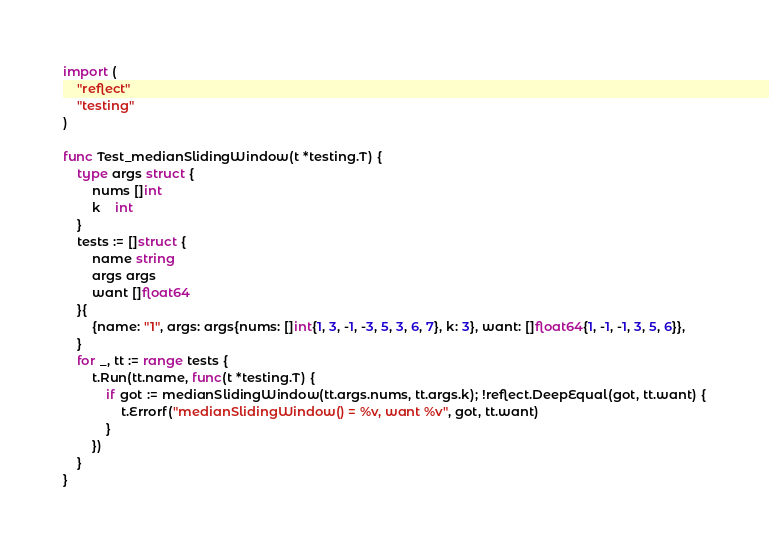<code> <loc_0><loc_0><loc_500><loc_500><_Go_>
import (
	"reflect"
	"testing"
)

func Test_medianSlidingWindow(t *testing.T) {
	type args struct {
		nums []int
		k    int
	}
	tests := []struct {
		name string
		args args
		want []float64
	}{
		{name: "1", args: args{nums: []int{1, 3, -1, -3, 5, 3, 6, 7}, k: 3}, want: []float64{1, -1, -1, 3, 5, 6}},
	}
	for _, tt := range tests {
		t.Run(tt.name, func(t *testing.T) {
			if got := medianSlidingWindow(tt.args.nums, tt.args.k); !reflect.DeepEqual(got, tt.want) {
				t.Errorf("medianSlidingWindow() = %v, want %v", got, tt.want)
			}
		})
	}
}
</code> 